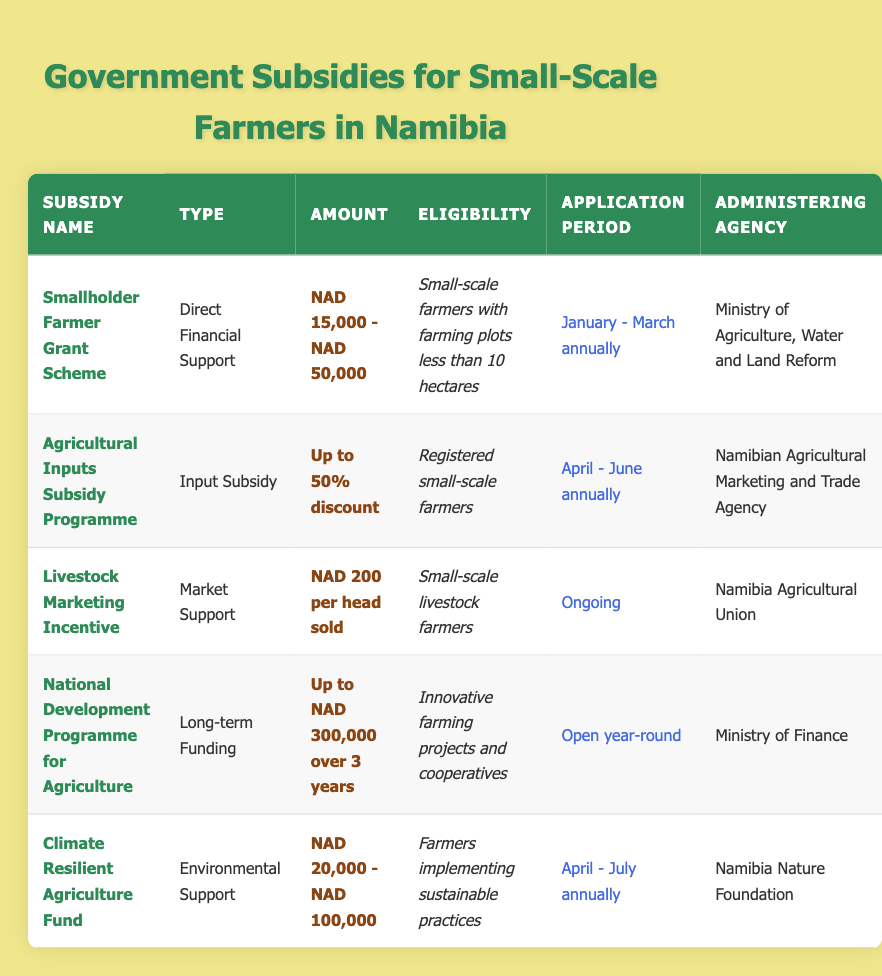What's the maximum amount available under the Smallholder Farmer Grant Scheme? According to the table, the Smallholder Farmer Grant Scheme offers an amount ranging from NAD 15,000 to NAD 50,000. The maximum amount within this range is NAD 50,000.
Answer: NAD 50,000 Which subsidy has the longest application period? The National Development Programme for Agriculture has an application period that is open year-round, which is longer than the other subsidies that have defined annual application periods.
Answer: Open year-round True or False: The Climate Resilient Agriculture Fund is only for small-scale farmers with less than 10 hectares of land. The Climate Resilient Agriculture Fund is specifically for farmers implementing sustainable practices, and there is no restriction mentioned regarding the size of their land. Therefore, this statement is false.
Answer: False What are the eligibility requirements for the Agricultural Inputs Subsidy Programme? The eligibility requirement for this programme is that applicants must be registered small-scale farmers. This information can be found in the eligibility column of the corresponding row in the table.
Answer: Registered small-scale farmers How much financial support can innovative farming projects receive from the National Development Programme for Agriculture over three years? The National Development Programme for Agriculture offers up to NAD 300,000 in funding spread over a duration of three years. This information is found in the amount column for the relevant subsidy in the table.
Answer: Up to NAD 300,000 What is the total amount range offered by the Climate Resilient Agriculture Fund? The Climate Resilient Agriculture Fund provides financial support ranging from NAD 20,000 to NAD 100,000. To find this range, I refer to the amount column in the table where the values are explicitly mentioned.
Answer: NAD 20,000 - NAD 100,000 How many subsidies are available for small-scale livestock farmers? From the table, there are two subsidies specifically for livestock farmers: the Livestock Marketing Incentive and the Smallholder Farmer Grant Scheme (if the farmer meets the land eligibility). Therefore, two subsidies are applicable.
Answer: Two subsidies Which agency administers the Agricultural Inputs Subsidy Programme? The agency that administers the Agricultural Inputs Subsidy Programme is the Namibian Agricultural Marketing and Trade Agency, which is listed in the administering agency column of the table corresponding to this subsidy.
Answer: Namibian Agricultural Marketing and Trade Agency 